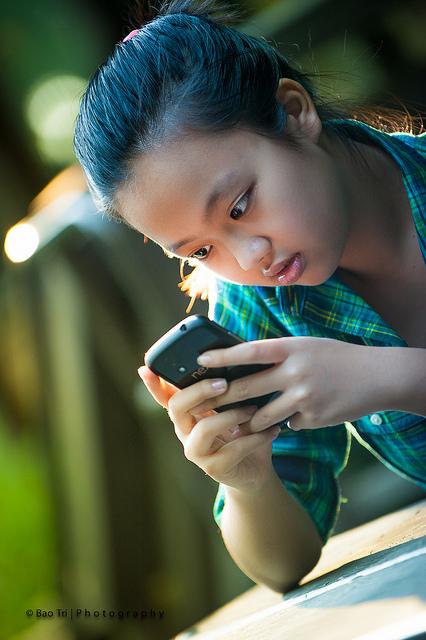What pattern is on her shirt?
Short answer required. Plaid. What is this girl doing?
Answer briefly. Texting. What is this child holding?
Keep it brief. Cell phone. 